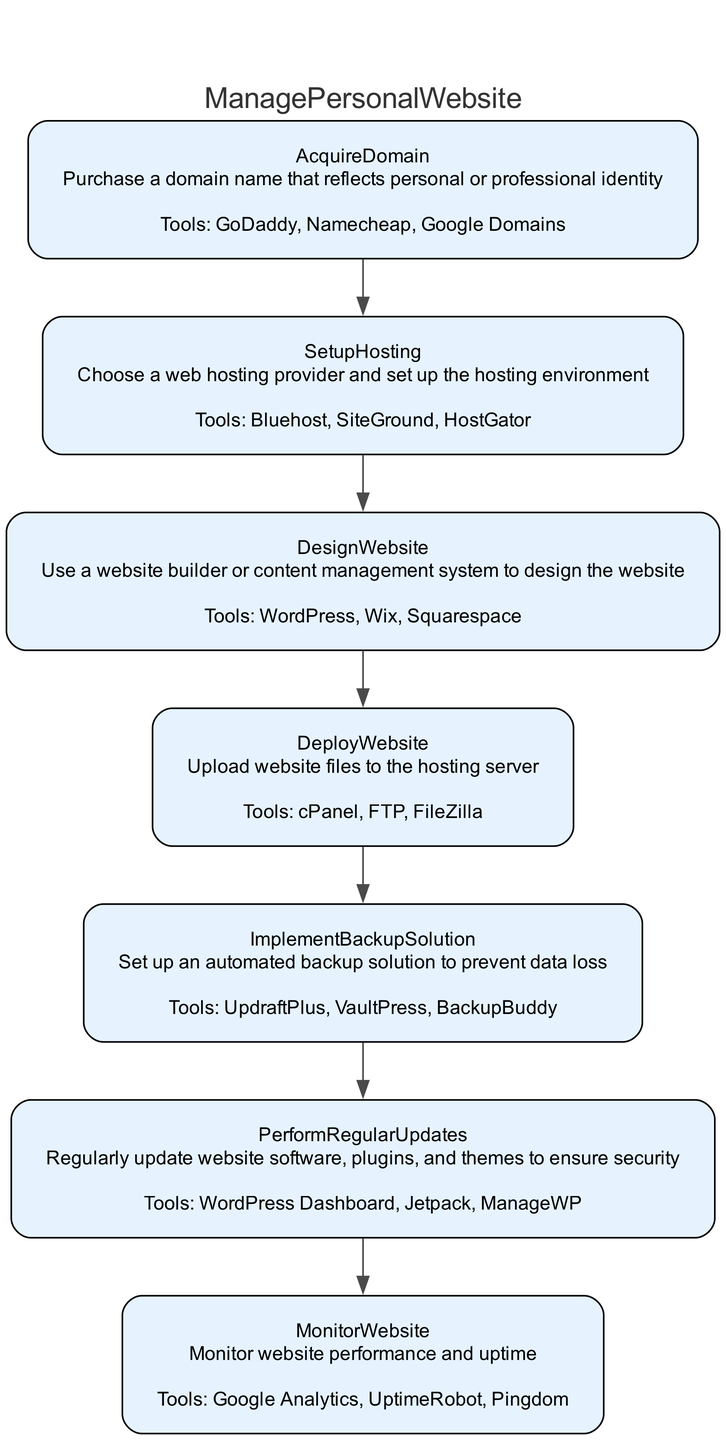What is the first step in managing a personal website? The diagram lists "AcquireDomain" as the first step, indicating that the initial action is to purchase a domain name.
Answer: AcquireDomain How many entities are associated with the "SetupHosting" step? The "SetupHosting" step includes three entities: Bluehost, SiteGround, and HostGator. Therefore, the count is three.
Answer: 3 What is the purpose of the "ImplementBackupSolution" step? The description for "ImplementBackupSolution" states it is about setting up an automated backup solution to prevent data loss, highlighting its critical role in maintaining data integrity.
Answer: Prevent data loss Which step comes immediately before "PerformRegularUpdates"? Following the flow of the diagram, "ImplementBackupSolution" directly leads to "PerformRegularUpdates," indicating it's the step that occurs just before updates are performed.
Answer: ImplementBackupSolution If a user skips "DesignWebsite," which step would they miss before "DeployWebsite"? Skipping "DesignWebsite" would mean directly going to "DeployWebsite," thus missing the essential step of designing the site prior to deploying it.
Answer: DesignWebsite What tools can be used in the "MonitorWebsite" step? The diagram lists Google Analytics, UptimeRobot, and Pingdom as the entities/tools for the "MonitorWebsite" step, providing options for performance monitoring.
Answer: Google Analytics, UptimeRobot, Pingdom How many steps are there in total in the diagram? By counting the individual steps in the diagram, we find there are seven steps from acquiring a domain to monitoring the website.
Answer: 7 What does the "DeployWebsite" step involve? The "DeployWebsite" step is described as the process of uploading website files to the hosting server, which is crucial for making the site accessible online.
Answer: Upload files to hosting server Which step ensures security by updating software and plugins? "PerformRegularUpdates" is described as the step focusing on regularly updating software, plugins, and themes to maintain security, making it key for safeguarding the site.
Answer: PerformRegularUpdates 